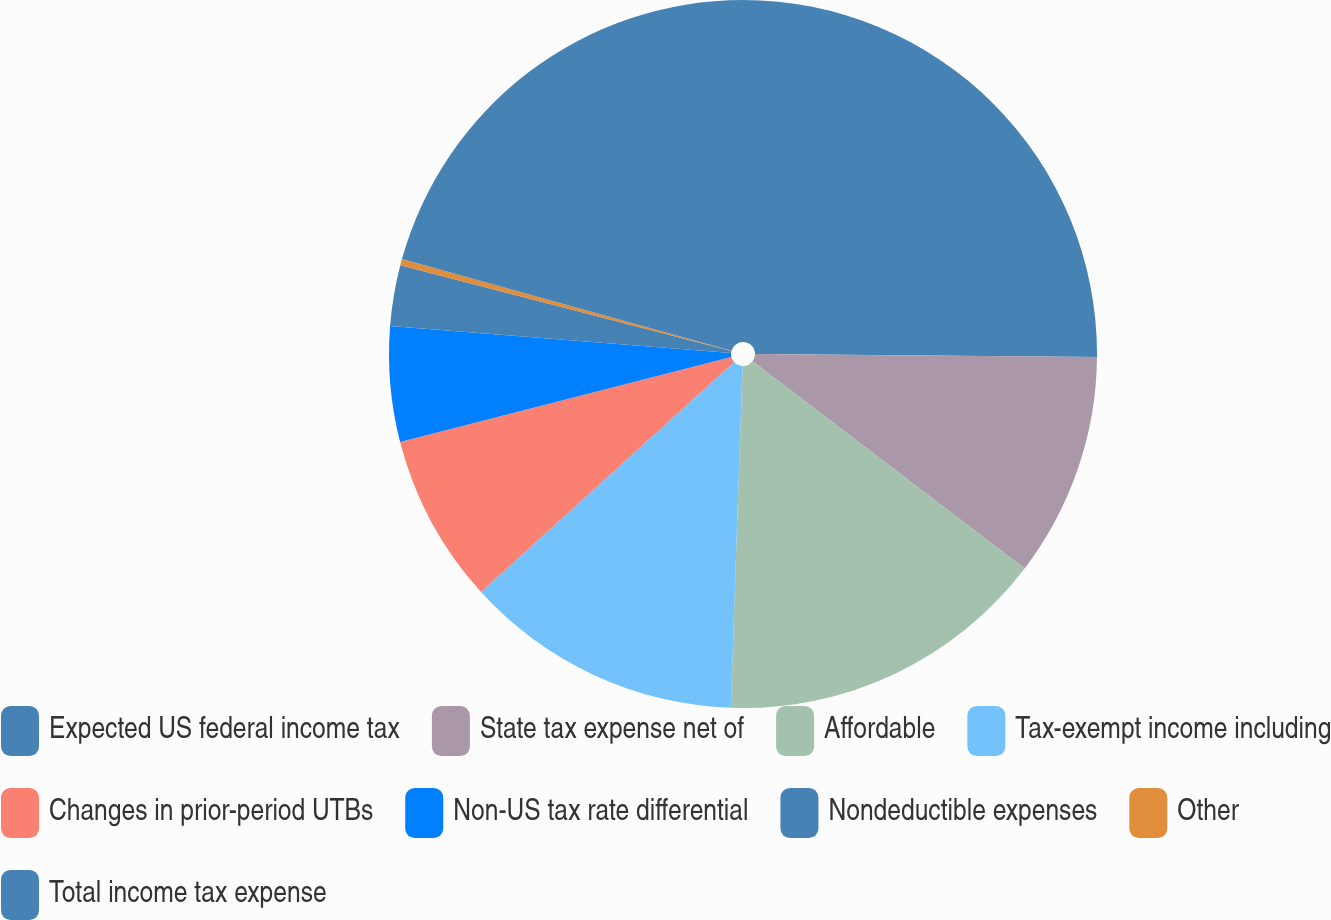Convert chart. <chart><loc_0><loc_0><loc_500><loc_500><pie_chart><fcel>Expected US federal income tax<fcel>State tax expense net of<fcel>Affordable<fcel>Tax-exempt income including<fcel>Changes in prior-period UTBs<fcel>Non-US tax rate differential<fcel>Nondeductible expenses<fcel>Other<fcel>Total income tax expense<nl><fcel>25.13%<fcel>10.23%<fcel>15.19%<fcel>12.71%<fcel>7.74%<fcel>5.26%<fcel>2.77%<fcel>0.29%<fcel>20.68%<nl></chart> 